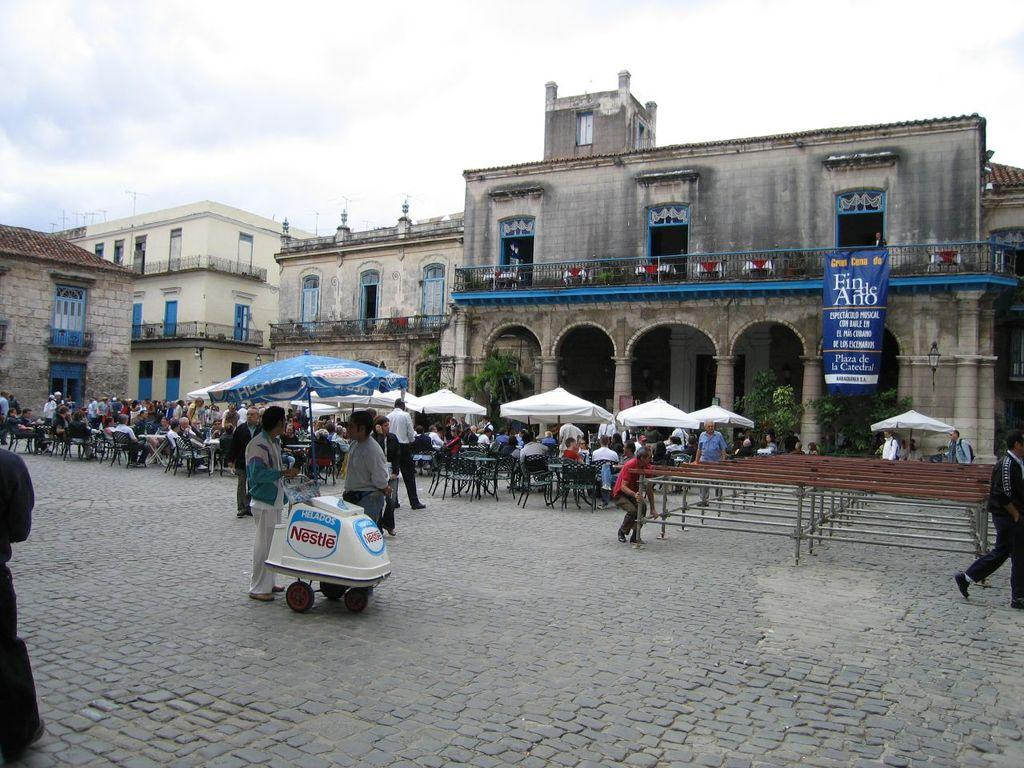How many people are in the image? There is a group of people in the image, but the exact number is not specified. What are some of the people in the image doing? Some people are sitting, and some people are standing. What objects are present to provide shade or protection from the elements? There are umbrellas in the image. What can be seen in the background of the image? There are buildings and the sky visible in the background of the image. What type of pies are being served to the people in the image? There is no mention of pies in the image; the main focus is on the people and their actions. What flavor of cream is being used to top the oatmeal in the image? There is no oatmeal or cream present in the image. 